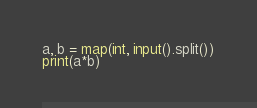Convert code to text. <code><loc_0><loc_0><loc_500><loc_500><_Python_>a, b = map(int, input().split())
print(a*b)</code> 